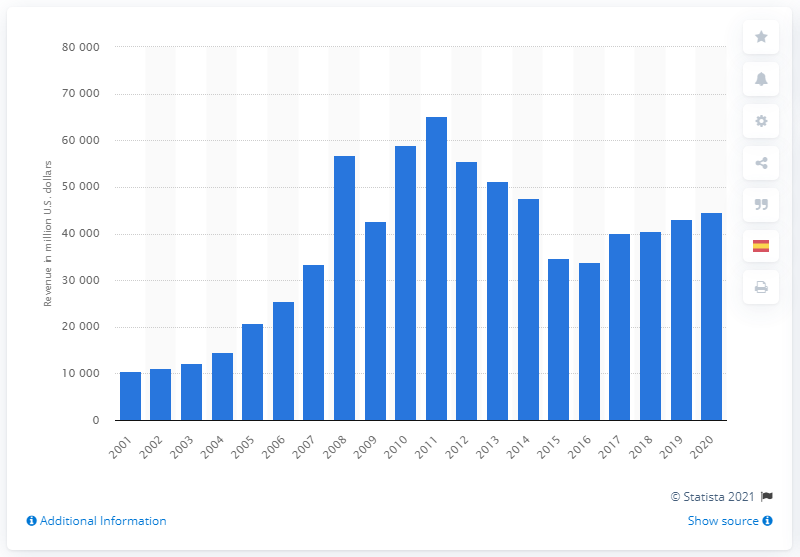Identify some key points in this picture. In 2020, Rio Tinto's gross sales revenue was 446,111. 